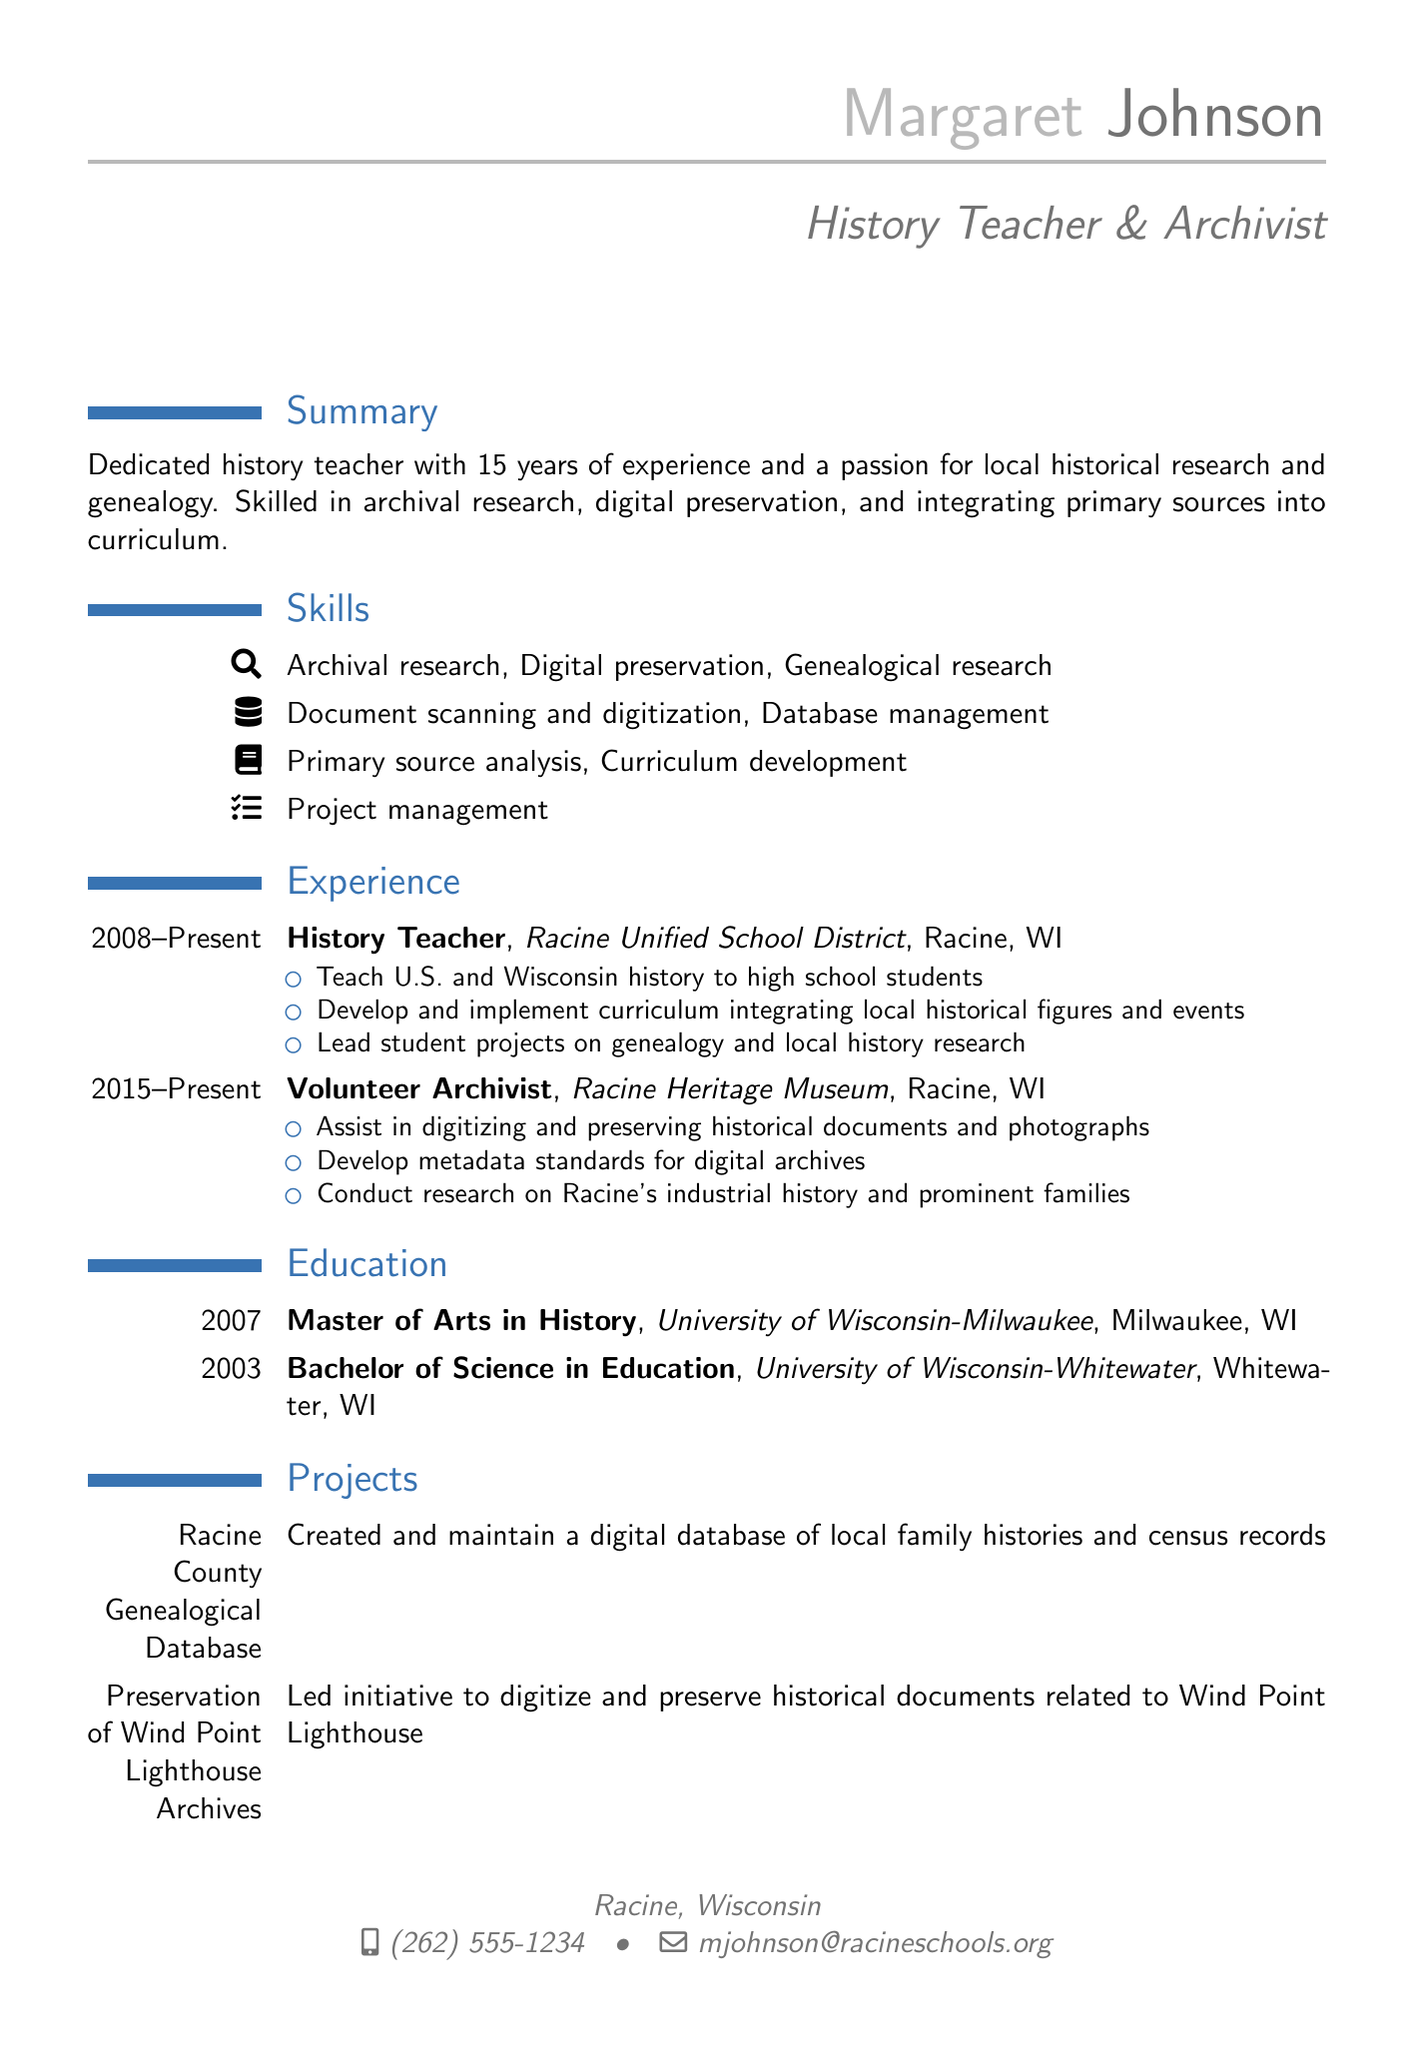What is the name of the individual? The name is listed at the top of the document as the individual’s name.
Answer: Margaret Johnson What position does Margaret Johnson hold? The document indicates her current job title under the experience section.
Answer: History Teacher How many years of experience does Margaret have? The summary mentions her total years of experience in history education.
Answer: 15 years What organization did Margaret volunteer for? The experience section details her volunteer work and the organization she is associated with.
Answer: Racine Heritage Museum What degree did Margaret earn in 2007? The education section specifies her degree and graduation year from the university.
Answer: Master of Arts in History What is one of the skills listed in the resume? The skills section enumerates different abilities relevant to the individual's qualifications.
Answer: Archival research Which project involves family histories? The projects section describes her work on specific projects, including one focused on genealogical data.
Answer: Racine County Genealogical Database What certification does Margaret have from the Academy of Certified Archivists? The certifications section lists her qualifications from relevant professional bodies.
Answer: Certified Archivist What city is Margaret's current workplace located in? The location of her job is highlighted in the experience section.
Answer: Racine, WI 